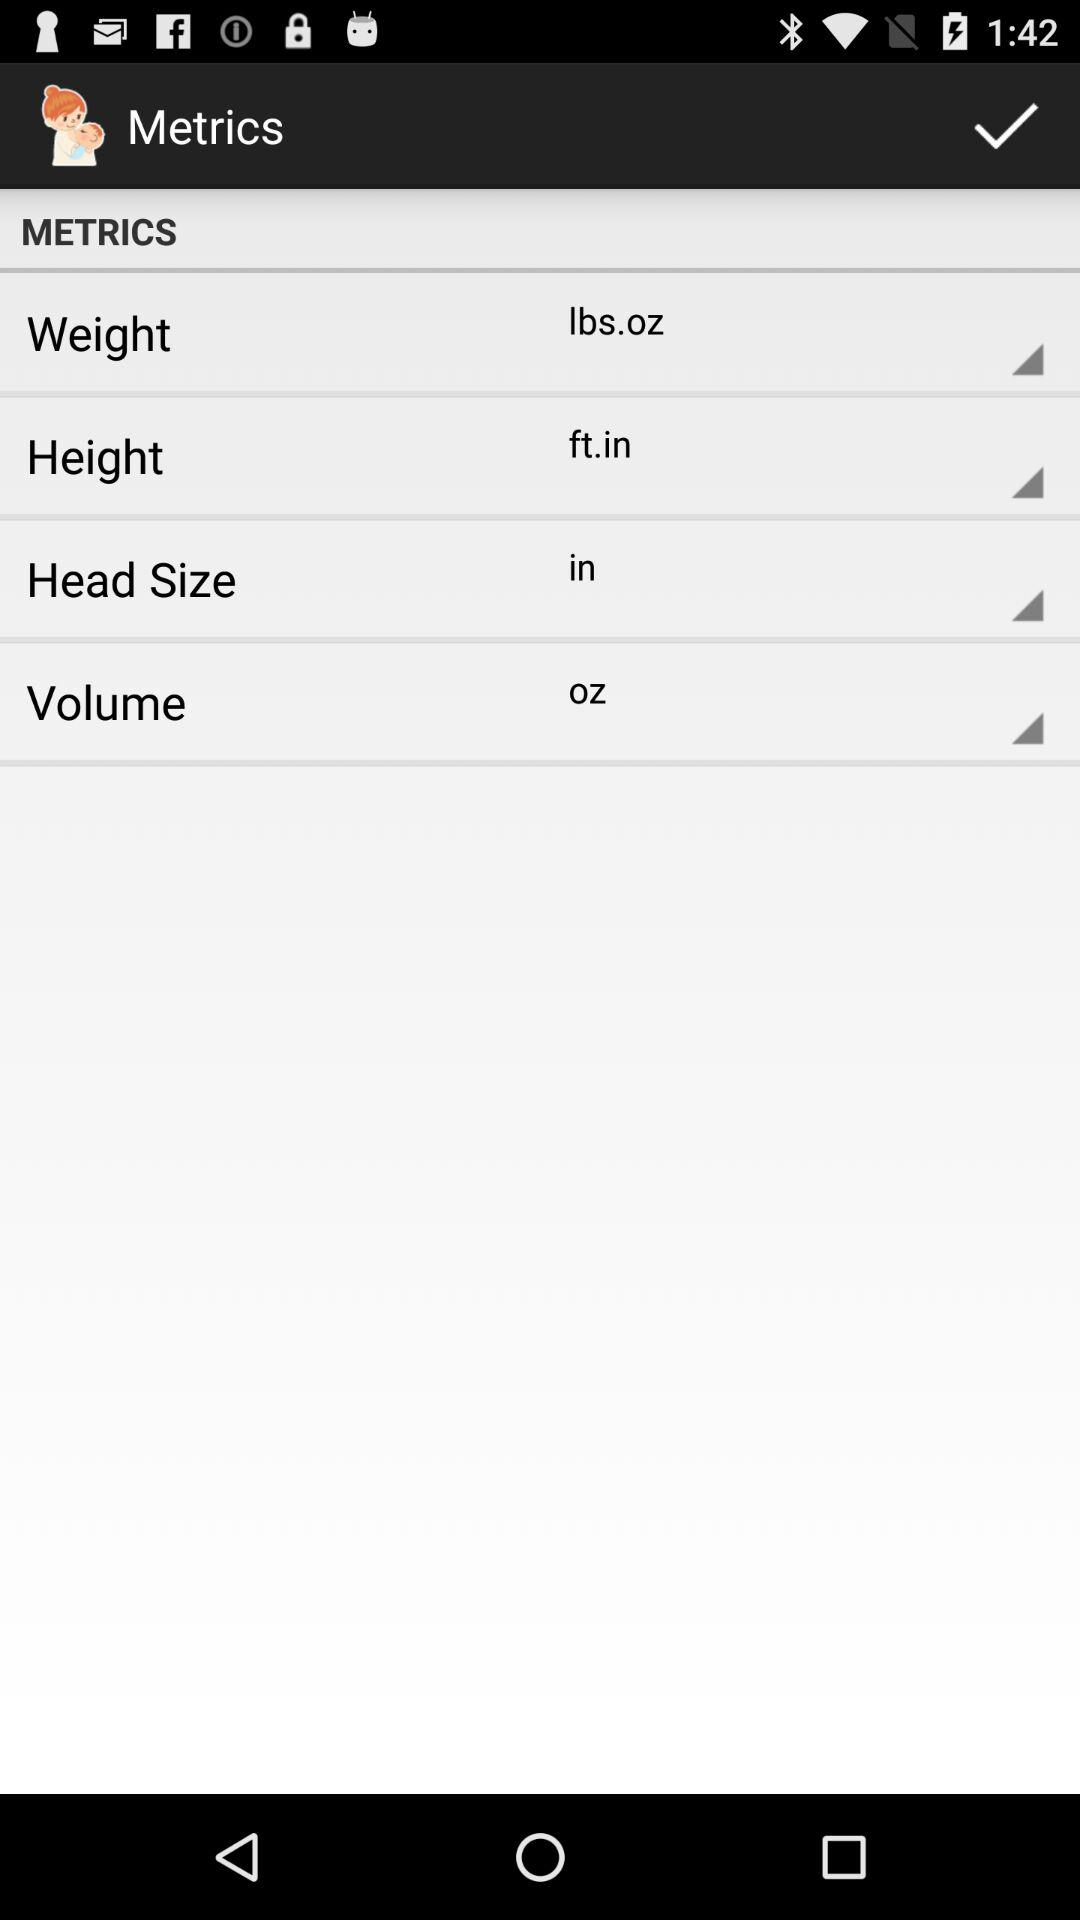What is the unit of head size? The unit of head size is inches. 